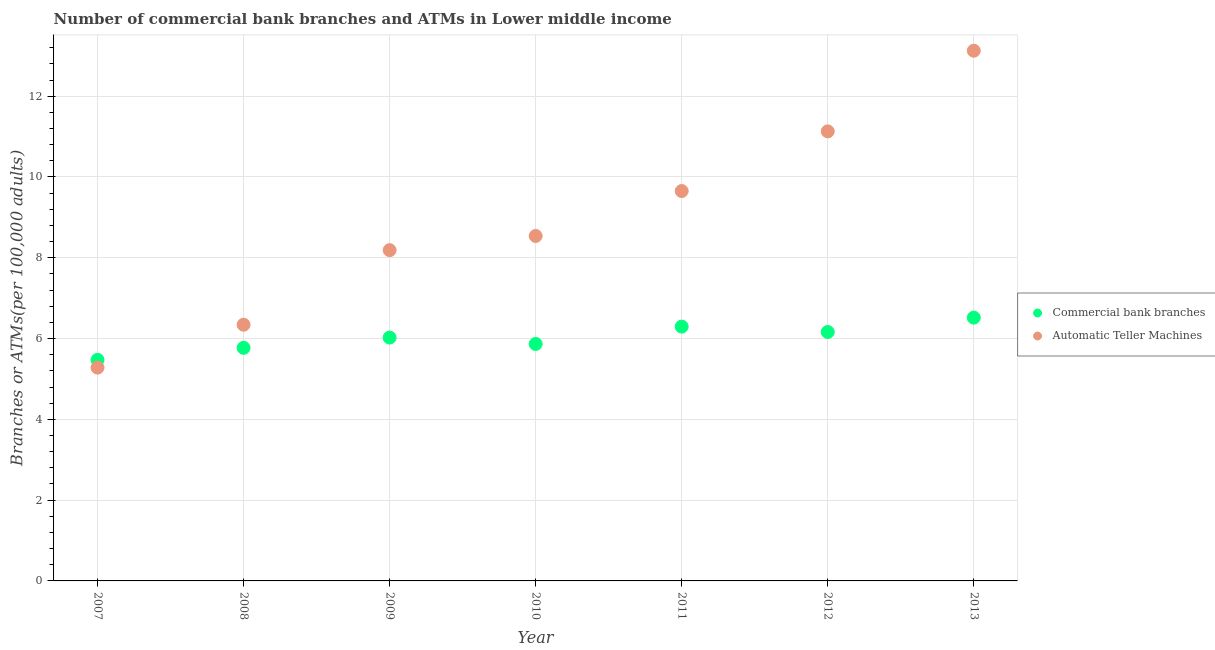How many different coloured dotlines are there?
Provide a short and direct response. 2. What is the number of atms in 2012?
Offer a very short reply. 11.13. Across all years, what is the maximum number of atms?
Offer a terse response. 13.13. Across all years, what is the minimum number of atms?
Your answer should be very brief. 5.28. In which year was the number of atms maximum?
Give a very brief answer. 2013. What is the total number of atms in the graph?
Your answer should be very brief. 62.26. What is the difference between the number of atms in 2007 and that in 2013?
Your answer should be very brief. -7.84. What is the difference between the number of commercal bank branches in 2011 and the number of atms in 2010?
Your response must be concise. -2.24. What is the average number of atms per year?
Give a very brief answer. 8.89. In the year 2007, what is the difference between the number of commercal bank branches and number of atms?
Offer a very short reply. 0.19. What is the ratio of the number of commercal bank branches in 2007 to that in 2010?
Provide a short and direct response. 0.93. Is the number of commercal bank branches in 2011 less than that in 2013?
Make the answer very short. Yes. What is the difference between the highest and the second highest number of commercal bank branches?
Offer a terse response. 0.22. What is the difference between the highest and the lowest number of commercal bank branches?
Offer a very short reply. 1.05. In how many years, is the number of atms greater than the average number of atms taken over all years?
Your answer should be compact. 3. Is the sum of the number of commercal bank branches in 2010 and 2012 greater than the maximum number of atms across all years?
Your answer should be very brief. No. Does the number of atms monotonically increase over the years?
Your response must be concise. Yes. Is the number of commercal bank branches strictly greater than the number of atms over the years?
Provide a succinct answer. No. Is the number of commercal bank branches strictly less than the number of atms over the years?
Ensure brevity in your answer.  No. How many dotlines are there?
Provide a succinct answer. 2. What is the difference between two consecutive major ticks on the Y-axis?
Offer a very short reply. 2. Does the graph contain any zero values?
Provide a short and direct response. No. Does the graph contain grids?
Provide a succinct answer. Yes. Where does the legend appear in the graph?
Ensure brevity in your answer.  Center right. How many legend labels are there?
Make the answer very short. 2. How are the legend labels stacked?
Give a very brief answer. Vertical. What is the title of the graph?
Offer a very short reply. Number of commercial bank branches and ATMs in Lower middle income. Does "Banks" appear as one of the legend labels in the graph?
Make the answer very short. No. What is the label or title of the X-axis?
Offer a terse response. Year. What is the label or title of the Y-axis?
Provide a short and direct response. Branches or ATMs(per 100,0 adults). What is the Branches or ATMs(per 100,000 adults) in Commercial bank branches in 2007?
Offer a very short reply. 5.47. What is the Branches or ATMs(per 100,000 adults) in Automatic Teller Machines in 2007?
Give a very brief answer. 5.28. What is the Branches or ATMs(per 100,000 adults) in Commercial bank branches in 2008?
Provide a short and direct response. 5.77. What is the Branches or ATMs(per 100,000 adults) of Automatic Teller Machines in 2008?
Provide a short and direct response. 6.34. What is the Branches or ATMs(per 100,000 adults) of Commercial bank branches in 2009?
Offer a very short reply. 6.02. What is the Branches or ATMs(per 100,000 adults) of Automatic Teller Machines in 2009?
Provide a short and direct response. 8.19. What is the Branches or ATMs(per 100,000 adults) in Commercial bank branches in 2010?
Your response must be concise. 5.87. What is the Branches or ATMs(per 100,000 adults) of Automatic Teller Machines in 2010?
Keep it short and to the point. 8.54. What is the Branches or ATMs(per 100,000 adults) in Commercial bank branches in 2011?
Give a very brief answer. 6.3. What is the Branches or ATMs(per 100,000 adults) of Automatic Teller Machines in 2011?
Offer a terse response. 9.65. What is the Branches or ATMs(per 100,000 adults) in Commercial bank branches in 2012?
Provide a succinct answer. 6.16. What is the Branches or ATMs(per 100,000 adults) in Automatic Teller Machines in 2012?
Make the answer very short. 11.13. What is the Branches or ATMs(per 100,000 adults) of Commercial bank branches in 2013?
Give a very brief answer. 6.52. What is the Branches or ATMs(per 100,000 adults) of Automatic Teller Machines in 2013?
Provide a short and direct response. 13.13. Across all years, what is the maximum Branches or ATMs(per 100,000 adults) of Commercial bank branches?
Offer a terse response. 6.52. Across all years, what is the maximum Branches or ATMs(per 100,000 adults) of Automatic Teller Machines?
Give a very brief answer. 13.13. Across all years, what is the minimum Branches or ATMs(per 100,000 adults) of Commercial bank branches?
Provide a short and direct response. 5.47. Across all years, what is the minimum Branches or ATMs(per 100,000 adults) in Automatic Teller Machines?
Offer a terse response. 5.28. What is the total Branches or ATMs(per 100,000 adults) of Commercial bank branches in the graph?
Your answer should be very brief. 42.11. What is the total Branches or ATMs(per 100,000 adults) of Automatic Teller Machines in the graph?
Provide a short and direct response. 62.26. What is the difference between the Branches or ATMs(per 100,000 adults) in Commercial bank branches in 2007 and that in 2008?
Your response must be concise. -0.3. What is the difference between the Branches or ATMs(per 100,000 adults) of Automatic Teller Machines in 2007 and that in 2008?
Your answer should be compact. -1.06. What is the difference between the Branches or ATMs(per 100,000 adults) in Commercial bank branches in 2007 and that in 2009?
Your answer should be very brief. -0.55. What is the difference between the Branches or ATMs(per 100,000 adults) of Automatic Teller Machines in 2007 and that in 2009?
Provide a succinct answer. -2.91. What is the difference between the Branches or ATMs(per 100,000 adults) in Commercial bank branches in 2007 and that in 2010?
Keep it short and to the point. -0.39. What is the difference between the Branches or ATMs(per 100,000 adults) in Automatic Teller Machines in 2007 and that in 2010?
Your answer should be compact. -3.26. What is the difference between the Branches or ATMs(per 100,000 adults) in Commercial bank branches in 2007 and that in 2011?
Offer a terse response. -0.82. What is the difference between the Branches or ATMs(per 100,000 adults) of Automatic Teller Machines in 2007 and that in 2011?
Give a very brief answer. -4.37. What is the difference between the Branches or ATMs(per 100,000 adults) of Commercial bank branches in 2007 and that in 2012?
Your answer should be compact. -0.69. What is the difference between the Branches or ATMs(per 100,000 adults) in Automatic Teller Machines in 2007 and that in 2012?
Your answer should be compact. -5.85. What is the difference between the Branches or ATMs(per 100,000 adults) of Commercial bank branches in 2007 and that in 2013?
Provide a short and direct response. -1.05. What is the difference between the Branches or ATMs(per 100,000 adults) of Automatic Teller Machines in 2007 and that in 2013?
Your response must be concise. -7.84. What is the difference between the Branches or ATMs(per 100,000 adults) of Commercial bank branches in 2008 and that in 2009?
Your answer should be very brief. -0.25. What is the difference between the Branches or ATMs(per 100,000 adults) of Automatic Teller Machines in 2008 and that in 2009?
Your answer should be compact. -1.85. What is the difference between the Branches or ATMs(per 100,000 adults) of Commercial bank branches in 2008 and that in 2010?
Provide a short and direct response. -0.1. What is the difference between the Branches or ATMs(per 100,000 adults) in Automatic Teller Machines in 2008 and that in 2010?
Your answer should be compact. -2.2. What is the difference between the Branches or ATMs(per 100,000 adults) of Commercial bank branches in 2008 and that in 2011?
Ensure brevity in your answer.  -0.53. What is the difference between the Branches or ATMs(per 100,000 adults) in Automatic Teller Machines in 2008 and that in 2011?
Keep it short and to the point. -3.31. What is the difference between the Branches or ATMs(per 100,000 adults) in Commercial bank branches in 2008 and that in 2012?
Your response must be concise. -0.39. What is the difference between the Branches or ATMs(per 100,000 adults) of Automatic Teller Machines in 2008 and that in 2012?
Give a very brief answer. -4.79. What is the difference between the Branches or ATMs(per 100,000 adults) in Commercial bank branches in 2008 and that in 2013?
Provide a succinct answer. -0.75. What is the difference between the Branches or ATMs(per 100,000 adults) of Automatic Teller Machines in 2008 and that in 2013?
Ensure brevity in your answer.  -6.78. What is the difference between the Branches or ATMs(per 100,000 adults) in Commercial bank branches in 2009 and that in 2010?
Offer a terse response. 0.16. What is the difference between the Branches or ATMs(per 100,000 adults) in Automatic Teller Machines in 2009 and that in 2010?
Your answer should be very brief. -0.35. What is the difference between the Branches or ATMs(per 100,000 adults) in Commercial bank branches in 2009 and that in 2011?
Give a very brief answer. -0.27. What is the difference between the Branches or ATMs(per 100,000 adults) in Automatic Teller Machines in 2009 and that in 2011?
Offer a terse response. -1.46. What is the difference between the Branches or ATMs(per 100,000 adults) in Commercial bank branches in 2009 and that in 2012?
Give a very brief answer. -0.14. What is the difference between the Branches or ATMs(per 100,000 adults) of Automatic Teller Machines in 2009 and that in 2012?
Provide a short and direct response. -2.94. What is the difference between the Branches or ATMs(per 100,000 adults) in Commercial bank branches in 2009 and that in 2013?
Provide a short and direct response. -0.49. What is the difference between the Branches or ATMs(per 100,000 adults) of Automatic Teller Machines in 2009 and that in 2013?
Provide a short and direct response. -4.94. What is the difference between the Branches or ATMs(per 100,000 adults) in Commercial bank branches in 2010 and that in 2011?
Provide a short and direct response. -0.43. What is the difference between the Branches or ATMs(per 100,000 adults) of Automatic Teller Machines in 2010 and that in 2011?
Your answer should be compact. -1.11. What is the difference between the Branches or ATMs(per 100,000 adults) in Commercial bank branches in 2010 and that in 2012?
Provide a succinct answer. -0.3. What is the difference between the Branches or ATMs(per 100,000 adults) in Automatic Teller Machines in 2010 and that in 2012?
Give a very brief answer. -2.59. What is the difference between the Branches or ATMs(per 100,000 adults) of Commercial bank branches in 2010 and that in 2013?
Make the answer very short. -0.65. What is the difference between the Branches or ATMs(per 100,000 adults) of Automatic Teller Machines in 2010 and that in 2013?
Offer a terse response. -4.59. What is the difference between the Branches or ATMs(per 100,000 adults) of Commercial bank branches in 2011 and that in 2012?
Make the answer very short. 0.13. What is the difference between the Branches or ATMs(per 100,000 adults) of Automatic Teller Machines in 2011 and that in 2012?
Your answer should be very brief. -1.48. What is the difference between the Branches or ATMs(per 100,000 adults) in Commercial bank branches in 2011 and that in 2013?
Provide a short and direct response. -0.22. What is the difference between the Branches or ATMs(per 100,000 adults) in Automatic Teller Machines in 2011 and that in 2013?
Provide a short and direct response. -3.47. What is the difference between the Branches or ATMs(per 100,000 adults) of Commercial bank branches in 2012 and that in 2013?
Your answer should be compact. -0.36. What is the difference between the Branches or ATMs(per 100,000 adults) of Automatic Teller Machines in 2012 and that in 2013?
Offer a terse response. -2. What is the difference between the Branches or ATMs(per 100,000 adults) of Commercial bank branches in 2007 and the Branches or ATMs(per 100,000 adults) of Automatic Teller Machines in 2008?
Offer a very short reply. -0.87. What is the difference between the Branches or ATMs(per 100,000 adults) of Commercial bank branches in 2007 and the Branches or ATMs(per 100,000 adults) of Automatic Teller Machines in 2009?
Keep it short and to the point. -2.72. What is the difference between the Branches or ATMs(per 100,000 adults) of Commercial bank branches in 2007 and the Branches or ATMs(per 100,000 adults) of Automatic Teller Machines in 2010?
Keep it short and to the point. -3.07. What is the difference between the Branches or ATMs(per 100,000 adults) in Commercial bank branches in 2007 and the Branches or ATMs(per 100,000 adults) in Automatic Teller Machines in 2011?
Provide a short and direct response. -4.18. What is the difference between the Branches or ATMs(per 100,000 adults) of Commercial bank branches in 2007 and the Branches or ATMs(per 100,000 adults) of Automatic Teller Machines in 2012?
Your answer should be very brief. -5.66. What is the difference between the Branches or ATMs(per 100,000 adults) of Commercial bank branches in 2007 and the Branches or ATMs(per 100,000 adults) of Automatic Teller Machines in 2013?
Offer a terse response. -7.65. What is the difference between the Branches or ATMs(per 100,000 adults) of Commercial bank branches in 2008 and the Branches or ATMs(per 100,000 adults) of Automatic Teller Machines in 2009?
Your answer should be very brief. -2.42. What is the difference between the Branches or ATMs(per 100,000 adults) in Commercial bank branches in 2008 and the Branches or ATMs(per 100,000 adults) in Automatic Teller Machines in 2010?
Your answer should be very brief. -2.77. What is the difference between the Branches or ATMs(per 100,000 adults) in Commercial bank branches in 2008 and the Branches or ATMs(per 100,000 adults) in Automatic Teller Machines in 2011?
Make the answer very short. -3.88. What is the difference between the Branches or ATMs(per 100,000 adults) in Commercial bank branches in 2008 and the Branches or ATMs(per 100,000 adults) in Automatic Teller Machines in 2012?
Make the answer very short. -5.36. What is the difference between the Branches or ATMs(per 100,000 adults) of Commercial bank branches in 2008 and the Branches or ATMs(per 100,000 adults) of Automatic Teller Machines in 2013?
Provide a short and direct response. -7.36. What is the difference between the Branches or ATMs(per 100,000 adults) of Commercial bank branches in 2009 and the Branches or ATMs(per 100,000 adults) of Automatic Teller Machines in 2010?
Your response must be concise. -2.52. What is the difference between the Branches or ATMs(per 100,000 adults) in Commercial bank branches in 2009 and the Branches or ATMs(per 100,000 adults) in Automatic Teller Machines in 2011?
Keep it short and to the point. -3.63. What is the difference between the Branches or ATMs(per 100,000 adults) of Commercial bank branches in 2009 and the Branches or ATMs(per 100,000 adults) of Automatic Teller Machines in 2012?
Provide a short and direct response. -5.11. What is the difference between the Branches or ATMs(per 100,000 adults) of Commercial bank branches in 2009 and the Branches or ATMs(per 100,000 adults) of Automatic Teller Machines in 2013?
Make the answer very short. -7.1. What is the difference between the Branches or ATMs(per 100,000 adults) in Commercial bank branches in 2010 and the Branches or ATMs(per 100,000 adults) in Automatic Teller Machines in 2011?
Give a very brief answer. -3.79. What is the difference between the Branches or ATMs(per 100,000 adults) of Commercial bank branches in 2010 and the Branches or ATMs(per 100,000 adults) of Automatic Teller Machines in 2012?
Provide a succinct answer. -5.26. What is the difference between the Branches or ATMs(per 100,000 adults) of Commercial bank branches in 2010 and the Branches or ATMs(per 100,000 adults) of Automatic Teller Machines in 2013?
Offer a very short reply. -7.26. What is the difference between the Branches or ATMs(per 100,000 adults) in Commercial bank branches in 2011 and the Branches or ATMs(per 100,000 adults) in Automatic Teller Machines in 2012?
Provide a succinct answer. -4.83. What is the difference between the Branches or ATMs(per 100,000 adults) of Commercial bank branches in 2011 and the Branches or ATMs(per 100,000 adults) of Automatic Teller Machines in 2013?
Give a very brief answer. -6.83. What is the difference between the Branches or ATMs(per 100,000 adults) in Commercial bank branches in 2012 and the Branches or ATMs(per 100,000 adults) in Automatic Teller Machines in 2013?
Ensure brevity in your answer.  -6.96. What is the average Branches or ATMs(per 100,000 adults) in Commercial bank branches per year?
Your response must be concise. 6.02. What is the average Branches or ATMs(per 100,000 adults) in Automatic Teller Machines per year?
Make the answer very short. 8.89. In the year 2007, what is the difference between the Branches or ATMs(per 100,000 adults) of Commercial bank branches and Branches or ATMs(per 100,000 adults) of Automatic Teller Machines?
Your response must be concise. 0.19. In the year 2008, what is the difference between the Branches or ATMs(per 100,000 adults) in Commercial bank branches and Branches or ATMs(per 100,000 adults) in Automatic Teller Machines?
Provide a succinct answer. -0.57. In the year 2009, what is the difference between the Branches or ATMs(per 100,000 adults) of Commercial bank branches and Branches or ATMs(per 100,000 adults) of Automatic Teller Machines?
Give a very brief answer. -2.16. In the year 2010, what is the difference between the Branches or ATMs(per 100,000 adults) of Commercial bank branches and Branches or ATMs(per 100,000 adults) of Automatic Teller Machines?
Your answer should be very brief. -2.67. In the year 2011, what is the difference between the Branches or ATMs(per 100,000 adults) of Commercial bank branches and Branches or ATMs(per 100,000 adults) of Automatic Teller Machines?
Give a very brief answer. -3.36. In the year 2012, what is the difference between the Branches or ATMs(per 100,000 adults) of Commercial bank branches and Branches or ATMs(per 100,000 adults) of Automatic Teller Machines?
Offer a very short reply. -4.97. In the year 2013, what is the difference between the Branches or ATMs(per 100,000 adults) of Commercial bank branches and Branches or ATMs(per 100,000 adults) of Automatic Teller Machines?
Your answer should be compact. -6.61. What is the ratio of the Branches or ATMs(per 100,000 adults) of Commercial bank branches in 2007 to that in 2008?
Your response must be concise. 0.95. What is the ratio of the Branches or ATMs(per 100,000 adults) in Automatic Teller Machines in 2007 to that in 2008?
Provide a short and direct response. 0.83. What is the ratio of the Branches or ATMs(per 100,000 adults) in Commercial bank branches in 2007 to that in 2009?
Your response must be concise. 0.91. What is the ratio of the Branches or ATMs(per 100,000 adults) in Automatic Teller Machines in 2007 to that in 2009?
Ensure brevity in your answer.  0.64. What is the ratio of the Branches or ATMs(per 100,000 adults) in Commercial bank branches in 2007 to that in 2010?
Your answer should be compact. 0.93. What is the ratio of the Branches or ATMs(per 100,000 adults) of Automatic Teller Machines in 2007 to that in 2010?
Give a very brief answer. 0.62. What is the ratio of the Branches or ATMs(per 100,000 adults) in Commercial bank branches in 2007 to that in 2011?
Make the answer very short. 0.87. What is the ratio of the Branches or ATMs(per 100,000 adults) of Automatic Teller Machines in 2007 to that in 2011?
Offer a terse response. 0.55. What is the ratio of the Branches or ATMs(per 100,000 adults) of Commercial bank branches in 2007 to that in 2012?
Your answer should be compact. 0.89. What is the ratio of the Branches or ATMs(per 100,000 adults) in Automatic Teller Machines in 2007 to that in 2012?
Ensure brevity in your answer.  0.47. What is the ratio of the Branches or ATMs(per 100,000 adults) of Commercial bank branches in 2007 to that in 2013?
Ensure brevity in your answer.  0.84. What is the ratio of the Branches or ATMs(per 100,000 adults) of Automatic Teller Machines in 2007 to that in 2013?
Your answer should be compact. 0.4. What is the ratio of the Branches or ATMs(per 100,000 adults) in Commercial bank branches in 2008 to that in 2009?
Offer a terse response. 0.96. What is the ratio of the Branches or ATMs(per 100,000 adults) of Automatic Teller Machines in 2008 to that in 2009?
Give a very brief answer. 0.77. What is the ratio of the Branches or ATMs(per 100,000 adults) in Commercial bank branches in 2008 to that in 2010?
Offer a very short reply. 0.98. What is the ratio of the Branches or ATMs(per 100,000 adults) in Automatic Teller Machines in 2008 to that in 2010?
Provide a short and direct response. 0.74. What is the ratio of the Branches or ATMs(per 100,000 adults) of Commercial bank branches in 2008 to that in 2011?
Offer a very short reply. 0.92. What is the ratio of the Branches or ATMs(per 100,000 adults) of Automatic Teller Machines in 2008 to that in 2011?
Ensure brevity in your answer.  0.66. What is the ratio of the Branches or ATMs(per 100,000 adults) in Commercial bank branches in 2008 to that in 2012?
Your answer should be very brief. 0.94. What is the ratio of the Branches or ATMs(per 100,000 adults) of Automatic Teller Machines in 2008 to that in 2012?
Make the answer very short. 0.57. What is the ratio of the Branches or ATMs(per 100,000 adults) of Commercial bank branches in 2008 to that in 2013?
Make the answer very short. 0.89. What is the ratio of the Branches or ATMs(per 100,000 adults) of Automatic Teller Machines in 2008 to that in 2013?
Make the answer very short. 0.48. What is the ratio of the Branches or ATMs(per 100,000 adults) in Commercial bank branches in 2009 to that in 2010?
Keep it short and to the point. 1.03. What is the ratio of the Branches or ATMs(per 100,000 adults) of Automatic Teller Machines in 2009 to that in 2010?
Give a very brief answer. 0.96. What is the ratio of the Branches or ATMs(per 100,000 adults) in Commercial bank branches in 2009 to that in 2011?
Your response must be concise. 0.96. What is the ratio of the Branches or ATMs(per 100,000 adults) in Automatic Teller Machines in 2009 to that in 2011?
Offer a very short reply. 0.85. What is the ratio of the Branches or ATMs(per 100,000 adults) of Commercial bank branches in 2009 to that in 2012?
Make the answer very short. 0.98. What is the ratio of the Branches or ATMs(per 100,000 adults) in Automatic Teller Machines in 2009 to that in 2012?
Give a very brief answer. 0.74. What is the ratio of the Branches or ATMs(per 100,000 adults) of Commercial bank branches in 2009 to that in 2013?
Ensure brevity in your answer.  0.92. What is the ratio of the Branches or ATMs(per 100,000 adults) of Automatic Teller Machines in 2009 to that in 2013?
Ensure brevity in your answer.  0.62. What is the ratio of the Branches or ATMs(per 100,000 adults) of Commercial bank branches in 2010 to that in 2011?
Give a very brief answer. 0.93. What is the ratio of the Branches or ATMs(per 100,000 adults) in Automatic Teller Machines in 2010 to that in 2011?
Give a very brief answer. 0.88. What is the ratio of the Branches or ATMs(per 100,000 adults) in Commercial bank branches in 2010 to that in 2012?
Make the answer very short. 0.95. What is the ratio of the Branches or ATMs(per 100,000 adults) of Automatic Teller Machines in 2010 to that in 2012?
Offer a very short reply. 0.77. What is the ratio of the Branches or ATMs(per 100,000 adults) of Automatic Teller Machines in 2010 to that in 2013?
Give a very brief answer. 0.65. What is the ratio of the Branches or ATMs(per 100,000 adults) in Commercial bank branches in 2011 to that in 2012?
Provide a succinct answer. 1.02. What is the ratio of the Branches or ATMs(per 100,000 adults) of Automatic Teller Machines in 2011 to that in 2012?
Give a very brief answer. 0.87. What is the ratio of the Branches or ATMs(per 100,000 adults) of Commercial bank branches in 2011 to that in 2013?
Your response must be concise. 0.97. What is the ratio of the Branches or ATMs(per 100,000 adults) of Automatic Teller Machines in 2011 to that in 2013?
Your answer should be very brief. 0.74. What is the ratio of the Branches or ATMs(per 100,000 adults) of Commercial bank branches in 2012 to that in 2013?
Ensure brevity in your answer.  0.95. What is the ratio of the Branches or ATMs(per 100,000 adults) in Automatic Teller Machines in 2012 to that in 2013?
Keep it short and to the point. 0.85. What is the difference between the highest and the second highest Branches or ATMs(per 100,000 adults) of Commercial bank branches?
Your answer should be very brief. 0.22. What is the difference between the highest and the second highest Branches or ATMs(per 100,000 adults) of Automatic Teller Machines?
Ensure brevity in your answer.  2. What is the difference between the highest and the lowest Branches or ATMs(per 100,000 adults) of Commercial bank branches?
Offer a very short reply. 1.05. What is the difference between the highest and the lowest Branches or ATMs(per 100,000 adults) of Automatic Teller Machines?
Offer a terse response. 7.84. 